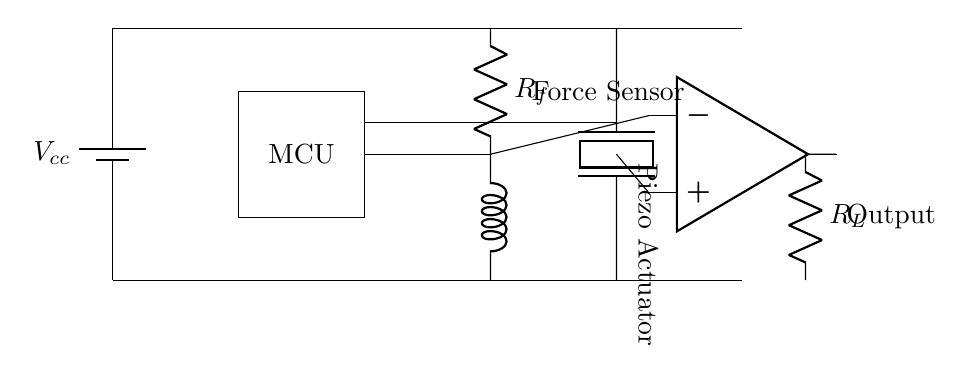What components are present in this circuit? The circuit diagram contains a battery, microcontroller, force sensor, piezoelectric actuator, operational amplifier, and a load resistor. Each component can be identified by examining the different symbols and labels present in the diagram.
Answer: battery, microcontroller, force sensor, piezoelectric actuator, operational amplifier, load resistor What is the role of the microcontroller in this circuit? The microcontroller acts as the control unit that processes the data from the force sensor and sends commands to the piezoelectric actuator based on this information. By examining the connections and position, it becomes clear that it is central to the operation of the haptic feedback system.
Answer: control unit Which component converts force into an electric signal? The force sensor is responsible for converting mechanical force into an electrical signal. This is evident from its placement in the circuit and the label that indicates its function.
Answer: force sensor What type of actuator is used in this circuit? The actuator used in this circuit is a piezoelectric actuator, which is specifically designed to produce haptic feedback. This is indicated by its label and the conventional symbol for a piezoelectric element in the circuit diagram.
Answer: piezoelectric actuator How is the output of the operational amplifier connected to the load? The output of the operational amplifier is connected directly to the load resistor, which is in series with it. Tracing the connection from the operational amplifier to the load resistor visually confirms this direct link in the circuit.
Answer: directly What is the purpose of the resistors in this circuit? The resistors in this circuit, including the load resistor and those associated with the force sensor, help to limit current and control feedback within the system. By examining their positions, it is clear they play critical roles in maintaining circuit stability and performance.
Answer: limit current and control feedback 